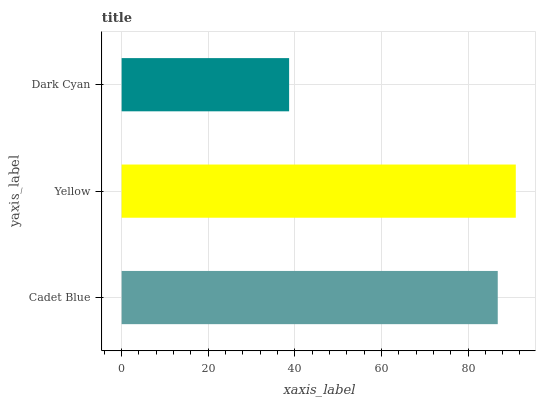Is Dark Cyan the minimum?
Answer yes or no. Yes. Is Yellow the maximum?
Answer yes or no. Yes. Is Yellow the minimum?
Answer yes or no. No. Is Dark Cyan the maximum?
Answer yes or no. No. Is Yellow greater than Dark Cyan?
Answer yes or no. Yes. Is Dark Cyan less than Yellow?
Answer yes or no. Yes. Is Dark Cyan greater than Yellow?
Answer yes or no. No. Is Yellow less than Dark Cyan?
Answer yes or no. No. Is Cadet Blue the high median?
Answer yes or no. Yes. Is Cadet Blue the low median?
Answer yes or no. Yes. Is Dark Cyan the high median?
Answer yes or no. No. Is Yellow the low median?
Answer yes or no. No. 